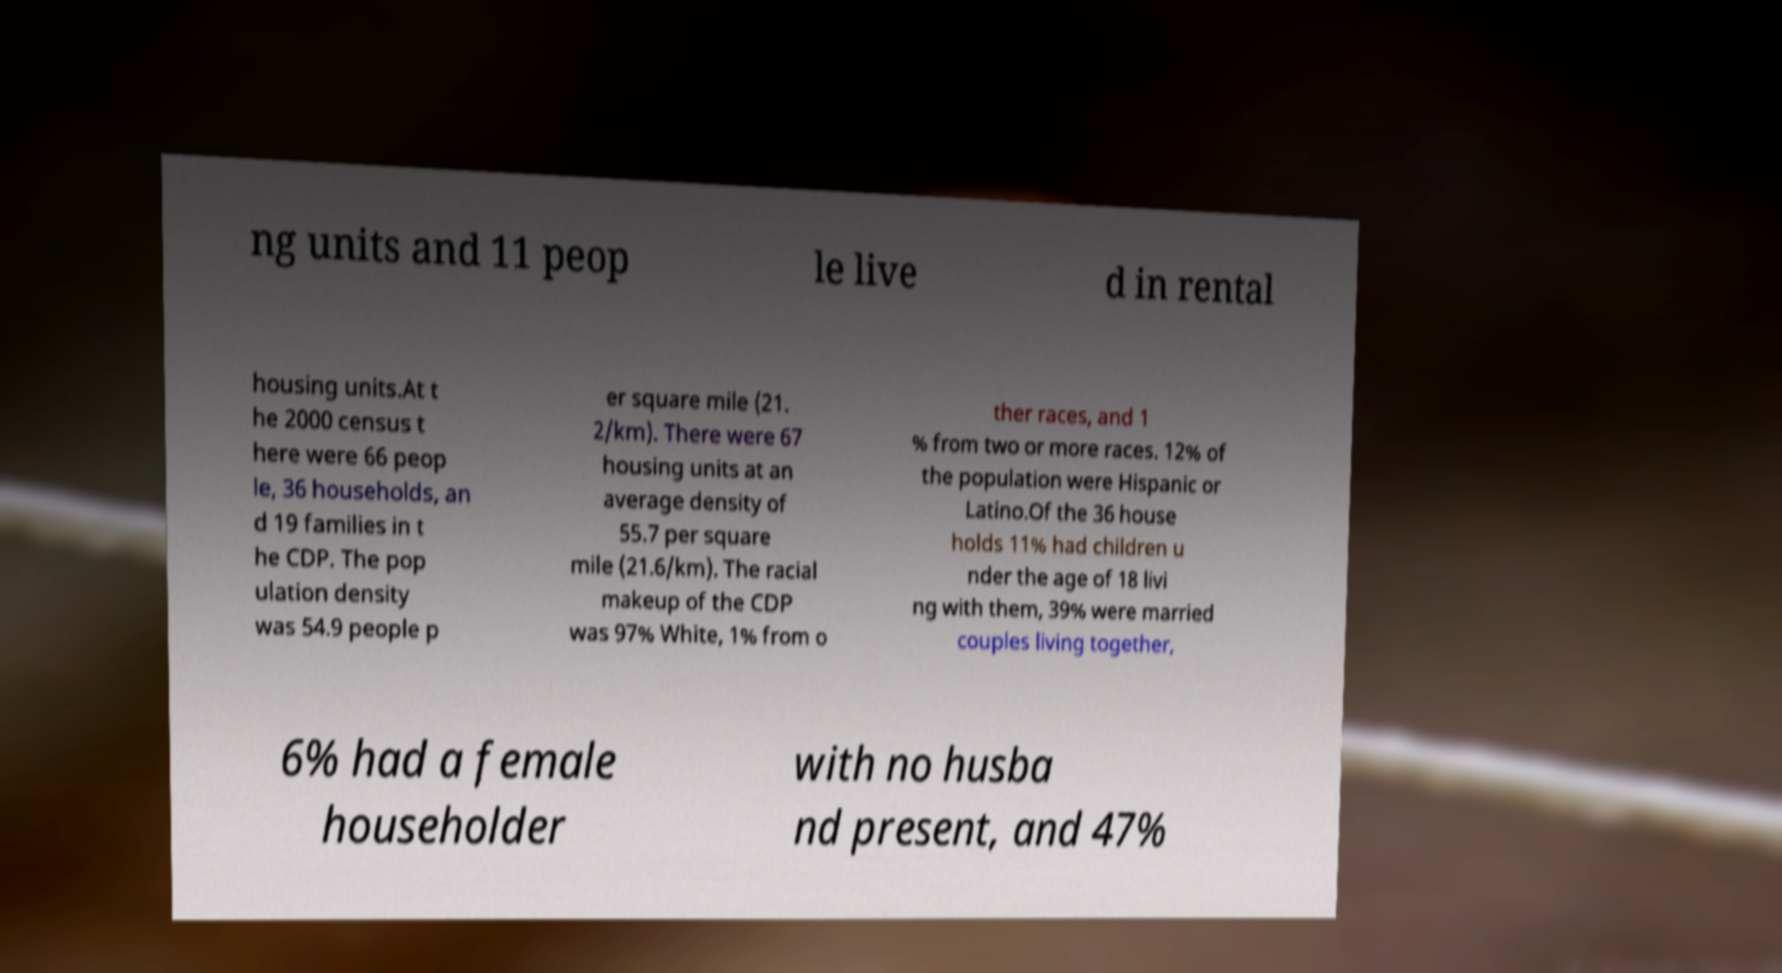I need the written content from this picture converted into text. Can you do that? ng units and 11 peop le live d in rental housing units.At t he 2000 census t here were 66 peop le, 36 households, an d 19 families in t he CDP. The pop ulation density was 54.9 people p er square mile (21. 2/km). There were 67 housing units at an average density of 55.7 per square mile (21.6/km). The racial makeup of the CDP was 97% White, 1% from o ther races, and 1 % from two or more races. 12% of the population were Hispanic or Latino.Of the 36 house holds 11% had children u nder the age of 18 livi ng with them, 39% were married couples living together, 6% had a female householder with no husba nd present, and 47% 